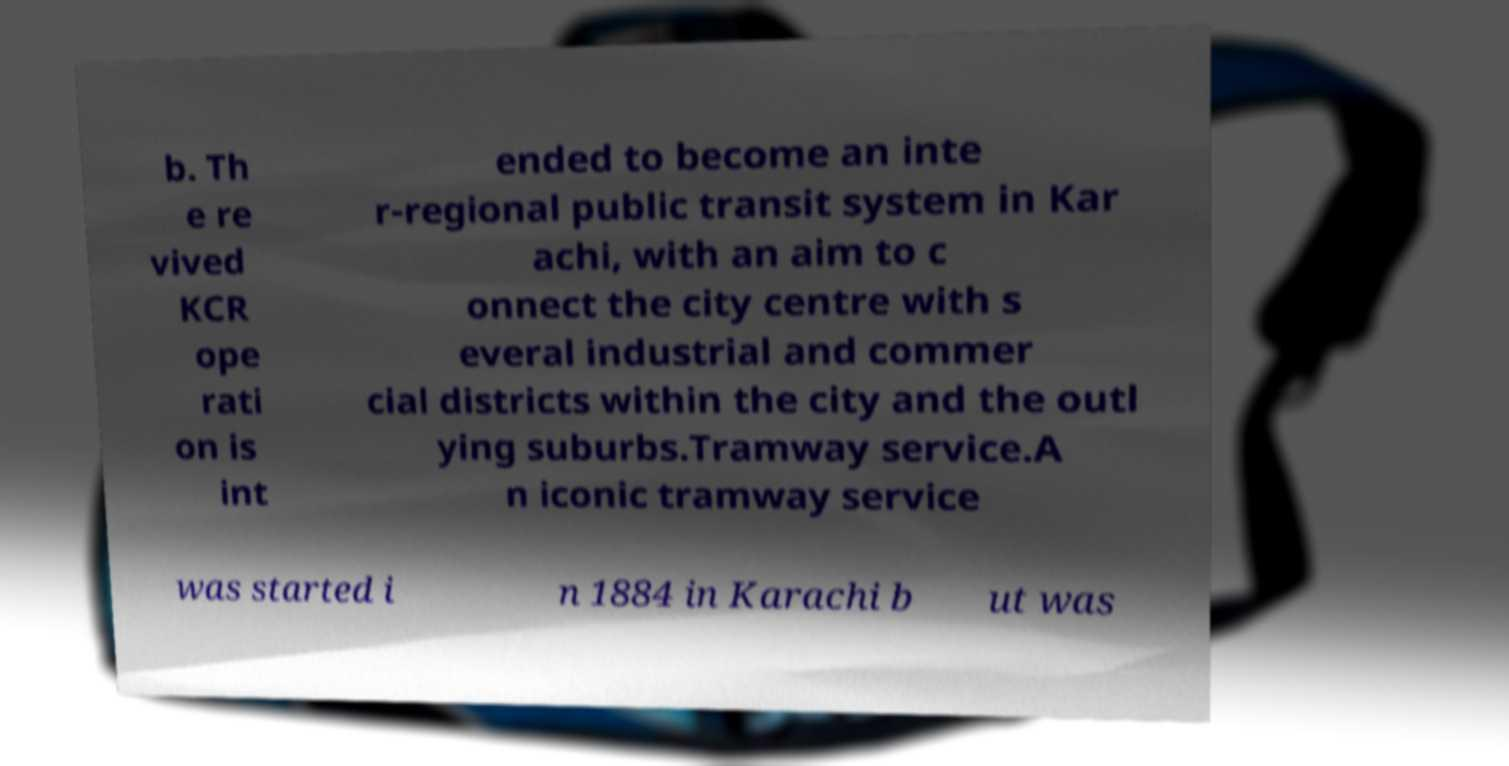Please identify and transcribe the text found in this image. b. Th e re vived KCR ope rati on is int ended to become an inte r-regional public transit system in Kar achi, with an aim to c onnect the city centre with s everal industrial and commer cial districts within the city and the outl ying suburbs.Tramway service.A n iconic tramway service was started i n 1884 in Karachi b ut was 